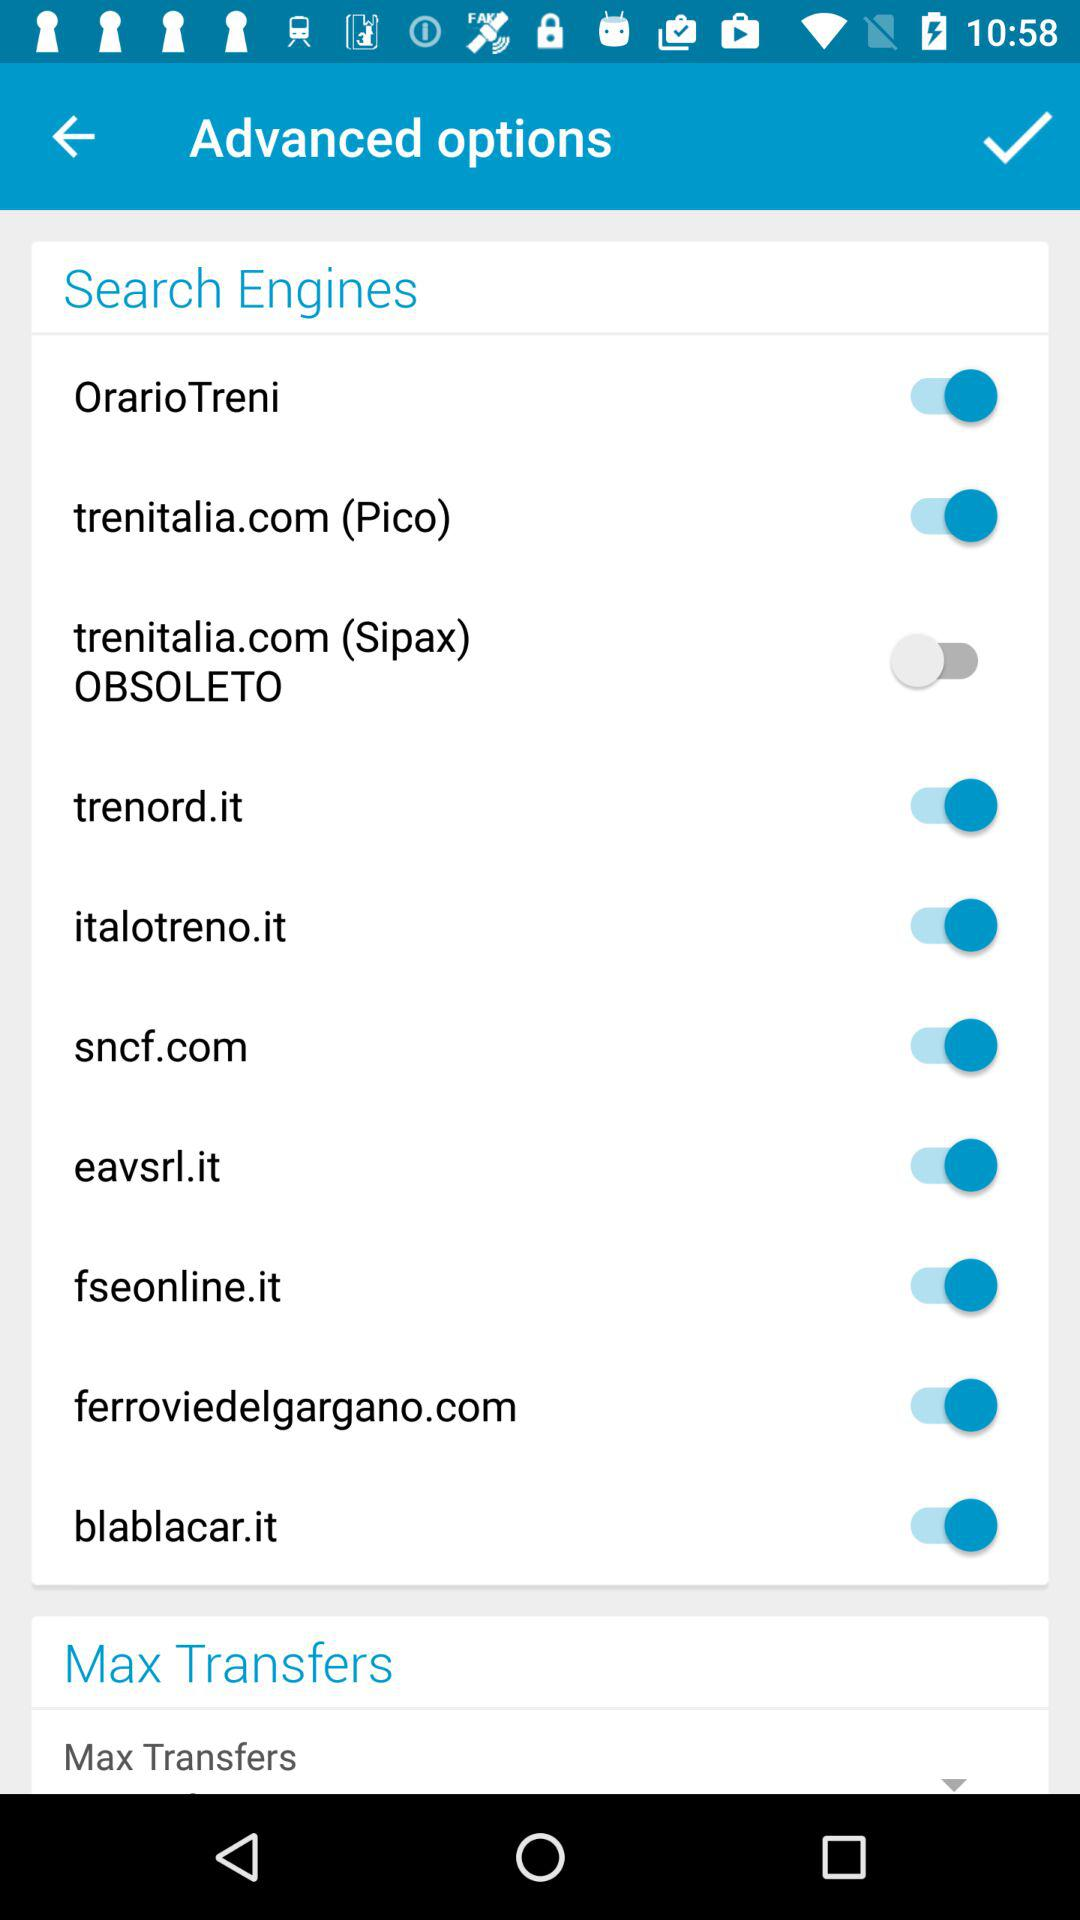What is the status of the "trenord.it"? The status is "on". 